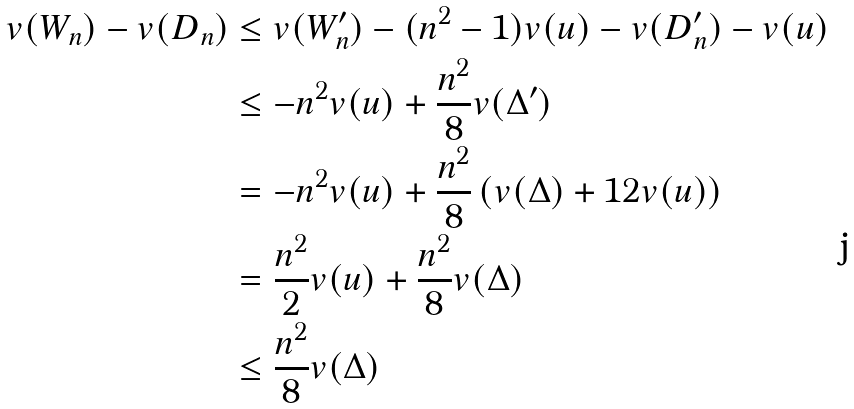<formula> <loc_0><loc_0><loc_500><loc_500>v ( W _ { n } ) - v ( D _ { n } ) & \leq v ( W _ { n } ^ { \prime } ) - ( n ^ { 2 } - 1 ) v ( u ) - v ( D _ { n } ^ { \prime } ) - v ( u ) \\ & \leq - n ^ { 2 } v ( u ) + \frac { n ^ { 2 } } { 8 } v ( \Delta ^ { \prime } ) \\ & = - n ^ { 2 } v ( u ) + \frac { n ^ { 2 } } { 8 } \left ( v ( \Delta ) + 1 2 v ( u ) \right ) \\ & = \frac { n ^ { 2 } } { 2 } v ( u ) + \frac { n ^ { 2 } } { 8 } v ( \Delta ) \\ & \leq \frac { n ^ { 2 } } { 8 } v ( \Delta )</formula> 